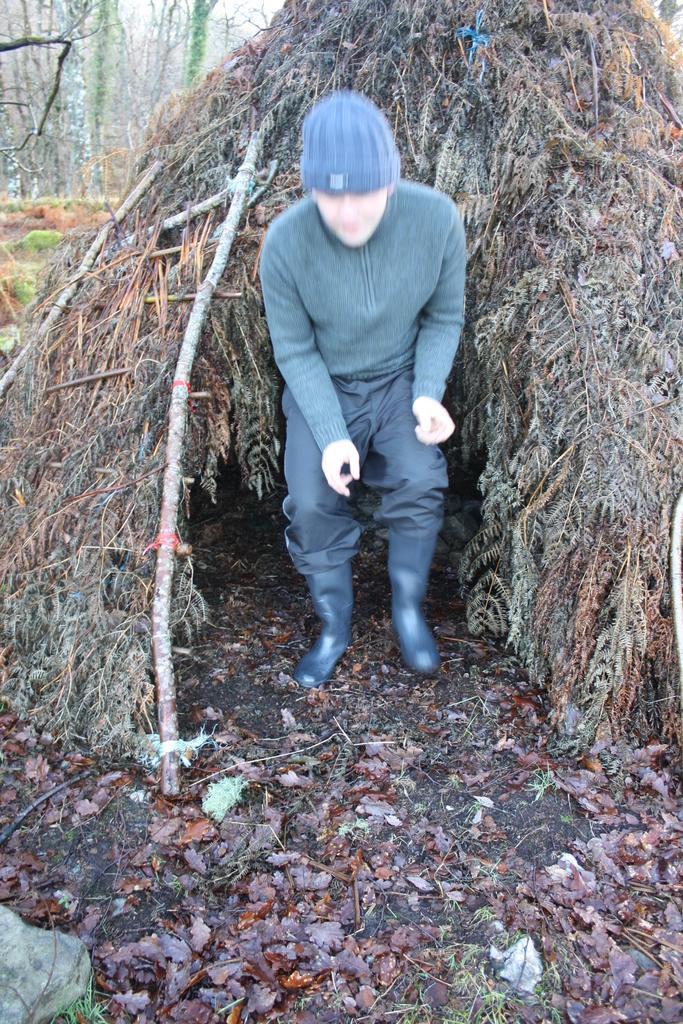Can you describe this image briefly? In this image I can see a person wearing dress and hat is standing on the ground, few leaves on the ground and the hut which is made of tree leaves. In the background I can see few trees and the sky. 